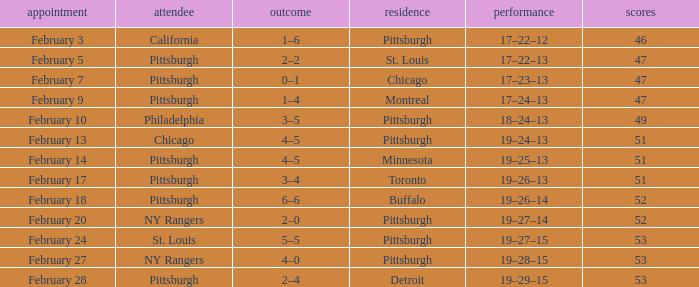Which Score has a Visitor of ny rangers, and a Record of 19–28–15? 4–0. Parse the table in full. {'header': ['appointment', 'attendee', 'outcome', 'residence', 'performance', 'scores'], 'rows': [['February 3', 'California', '1–6', 'Pittsburgh', '17–22–12', '46'], ['February 5', 'Pittsburgh', '2–2', 'St. Louis', '17–22–13', '47'], ['February 7', 'Pittsburgh', '0–1', 'Chicago', '17–23–13', '47'], ['February 9', 'Pittsburgh', '1–4', 'Montreal', '17–24–13', '47'], ['February 10', 'Philadelphia', '3–5', 'Pittsburgh', '18–24–13', '49'], ['February 13', 'Chicago', '4–5', 'Pittsburgh', '19–24–13', '51'], ['February 14', 'Pittsburgh', '4–5', 'Minnesota', '19–25–13', '51'], ['February 17', 'Pittsburgh', '3–4', 'Toronto', '19–26–13', '51'], ['February 18', 'Pittsburgh', '6–6', 'Buffalo', '19–26–14', '52'], ['February 20', 'NY Rangers', '2–0', 'Pittsburgh', '19–27–14', '52'], ['February 24', 'St. Louis', '5–5', 'Pittsburgh', '19–27–15', '53'], ['February 27', 'NY Rangers', '4–0', 'Pittsburgh', '19–28–15', '53'], ['February 28', 'Pittsburgh', '2–4', 'Detroit', '19–29–15', '53']]} 